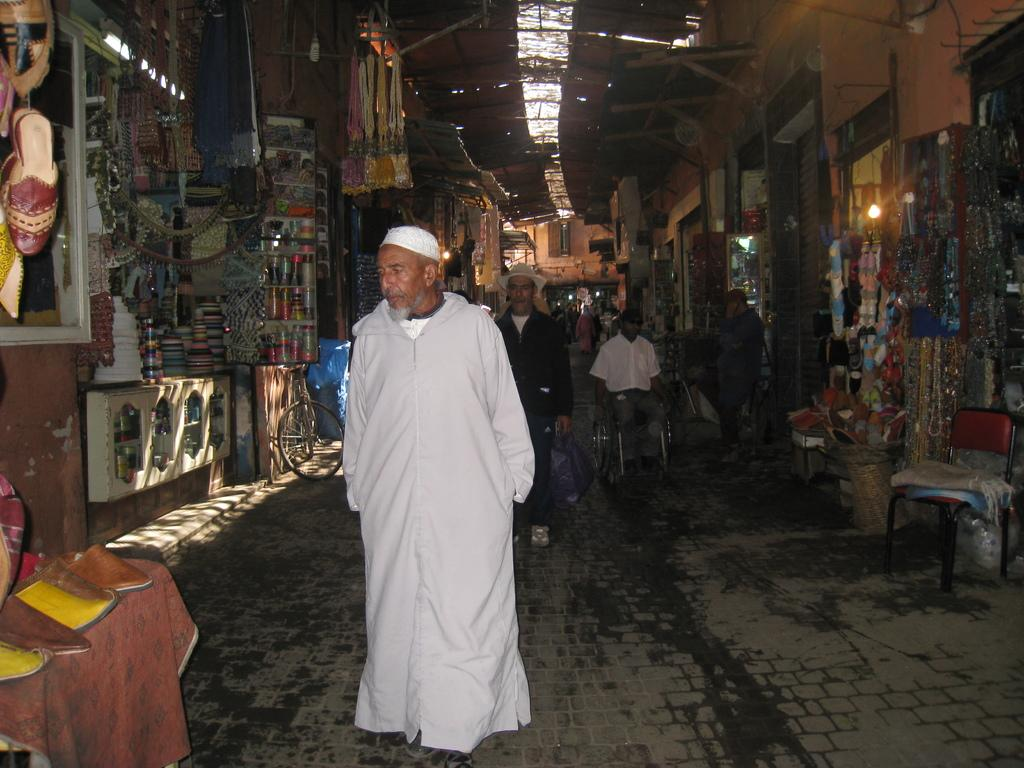What type of structure can be seen in the image? There is a wall in the image. What type of establishments are present in the image? There are shops in the image. What are the people in the image doing? People are walking on the road in the image. What time of day is it in the image, and what is the prison like? The time of day is not mentioned in the image, and there is no prison present in the image. 